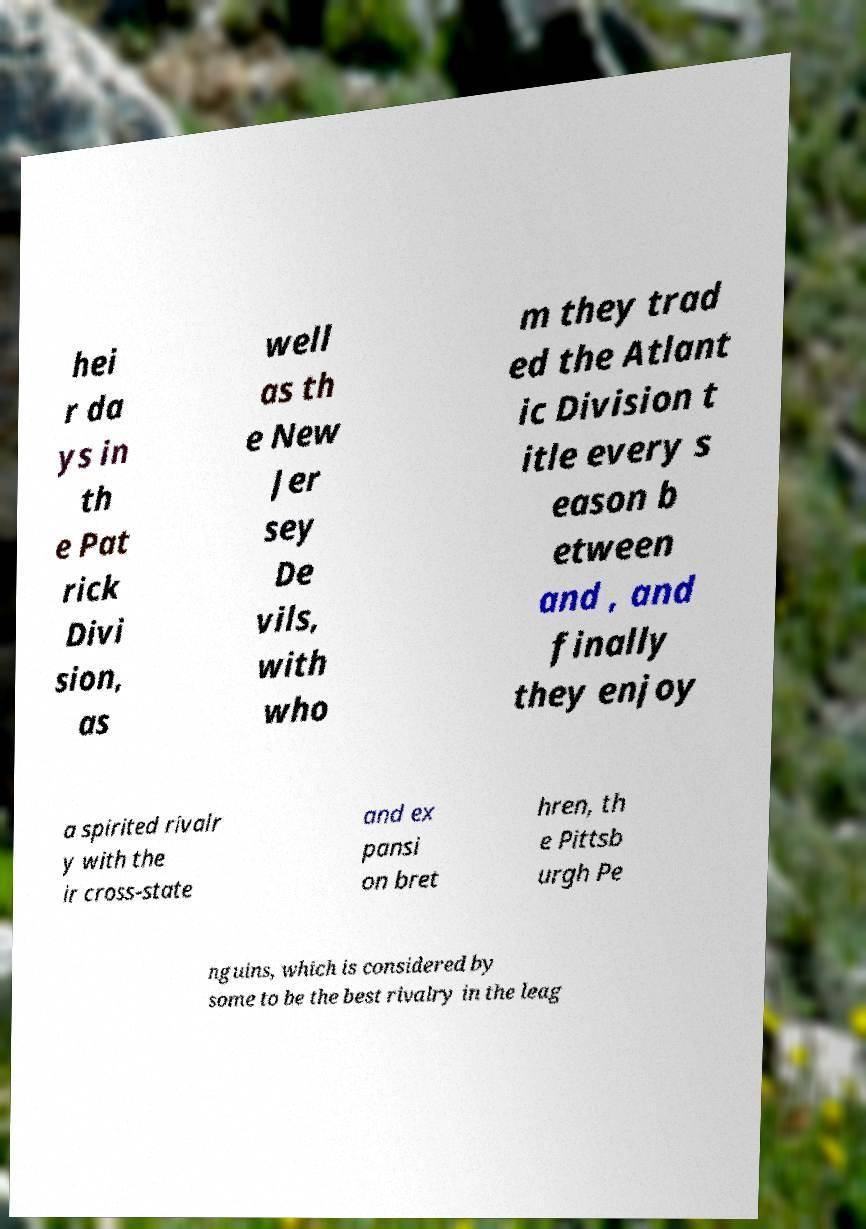For documentation purposes, I need the text within this image transcribed. Could you provide that? hei r da ys in th e Pat rick Divi sion, as well as th e New Jer sey De vils, with who m they trad ed the Atlant ic Division t itle every s eason b etween and , and finally they enjoy a spirited rivalr y with the ir cross-state and ex pansi on bret hren, th e Pittsb urgh Pe nguins, which is considered by some to be the best rivalry in the leag 